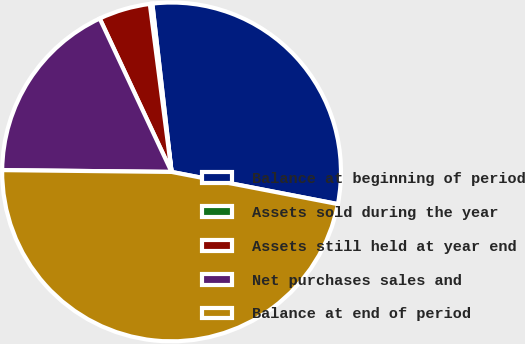<chart> <loc_0><loc_0><loc_500><loc_500><pie_chart><fcel>Balance at beginning of period<fcel>Assets sold during the year<fcel>Assets still held at year end<fcel>Net purchases sales and<fcel>Balance at end of period<nl><fcel>29.85%<fcel>0.24%<fcel>4.92%<fcel>17.86%<fcel>47.13%<nl></chart> 